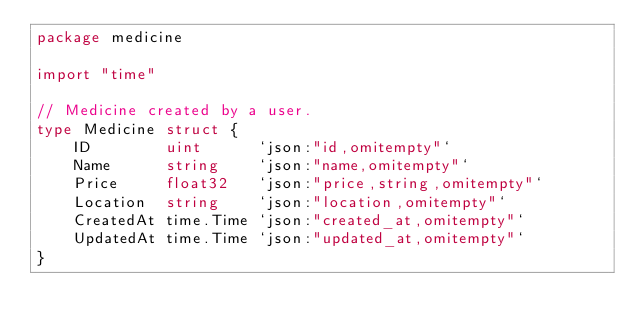Convert code to text. <code><loc_0><loc_0><loc_500><loc_500><_Go_>package medicine

import "time"

// Medicine created by a user.
type Medicine struct {
	ID        uint      `json:"id,omitempty"`
	Name      string    `json:"name,omitempty"`
	Price     float32   `json:"price,string,omitempty"`
	Location  string    `json:"location,omitempty"`
	CreatedAt time.Time `json:"created_at,omitempty"`
	UpdatedAt time.Time `json:"updated_at,omitempty"`
}
</code> 